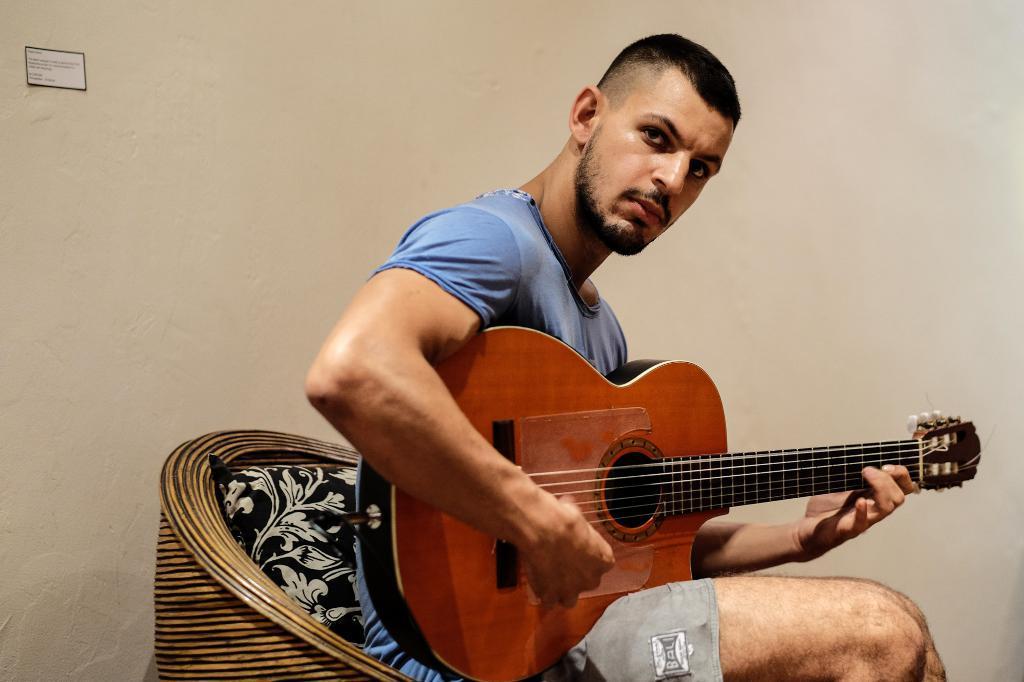Can you describe this image briefly? In this image the person is holding the guitar and he sitting on the chair and background is white. 